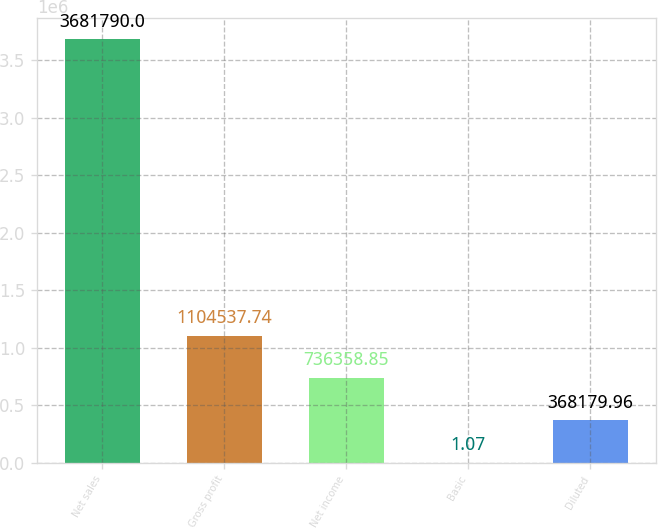Convert chart to OTSL. <chart><loc_0><loc_0><loc_500><loc_500><bar_chart><fcel>Net sales<fcel>Gross profit<fcel>Net income<fcel>Basic<fcel>Diluted<nl><fcel>3.68179e+06<fcel>1.10454e+06<fcel>736359<fcel>1.07<fcel>368180<nl></chart> 